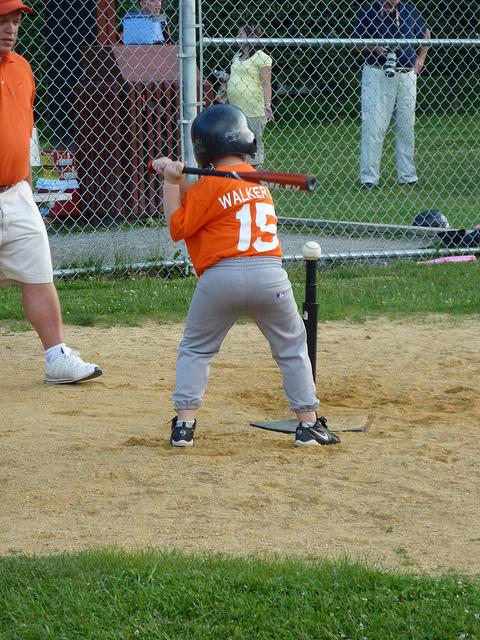Is the boy wearing a glove?
Give a very brief answer. No. Will someone be pitching the ball to the batter?
Answer briefly. No. What is the name of this hitter?
Short answer required. Walker. What is the boy standing on?
Short answer required. Dirt. Is the batter wearing gloves?
Concise answer only. No. What color is the player's uniform?
Concise answer only. Orange and gray. What is the number on the batters shirt?
Write a very short answer. 15. What sport is being played?
Be succinct. Baseball. What are the colors of the uniforms?
Short answer required. Orange and gray. IS the boy right handed?
Give a very brief answer. No. How many shirts is the boy wearing?
Short answer required. 1. Are all the players wearing long pants?
Keep it brief. Yes. Are there batting helmets?
Keep it brief. Yes. What ethnicity is the last name?
Give a very brief answer. English. What color are the players pants?
Keep it brief. Gray. What sport is this?
Write a very short answer. Tee ball. What color are the batter's socks?
Write a very short answer. White. What color is the boy's shirt?
Write a very short answer. Orange. Will the boy hit the ball?
Write a very short answer. Yes. What brand of bat?
Concise answer only. Telex. Which arm is raised in the air?
Keep it brief. Left. What type of shoes are on his feet?
Keep it brief. Sneakers. What is the Jersey number of the hitter?
Quick response, please. 15. What is his jersey number?
Concise answer only. 15. What is the last name of the batter?
Concise answer only. Walker. What is the catcher wearing on his head?
Short answer required. Helmet. What number is this player?
Write a very short answer. 15. How many people are holding bats?
Give a very brief answer. 1. What number is on the player's shirt?
Write a very short answer. 15. 